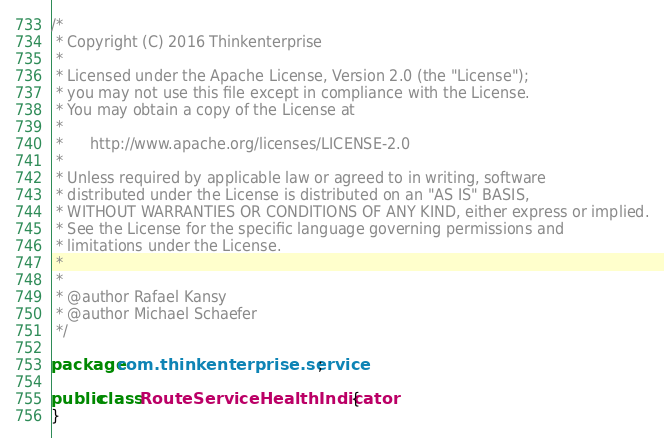Convert code to text. <code><loc_0><loc_0><loc_500><loc_500><_Java_>/*
 * Copyright (C) 2016 Thinkenterprise
 *
 * Licensed under the Apache License, Version 2.0 (the "License");
 * you may not use this file except in compliance with the License.
 * You may obtain a copy of the License at
 *
 *      http://www.apache.org/licenses/LICENSE-2.0
 *
 * Unless required by applicable law or agreed to in writing, software
 * distributed under the License is distributed on an "AS IS" BASIS,
 * WITHOUT WARRANTIES OR CONDITIONS OF ANY KIND, either express or implied.
 * See the License for the specific language governing permissions and
 * limitations under the License.
 *
 *
 * @author Rafael Kansy
 * @author Michael Schaefer
 */

package com.thinkenterprise.service;

public class RouteServiceHealthIndicator {
}
</code> 